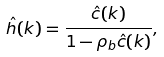<formula> <loc_0><loc_0><loc_500><loc_500>\hat { h } ( k ) = \frac { \hat { c } ( k ) } { 1 - \rho _ { b } \hat { c } ( k ) } ,</formula> 